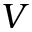Convert formula to latex. <formula><loc_0><loc_0><loc_500><loc_500>V</formula> 